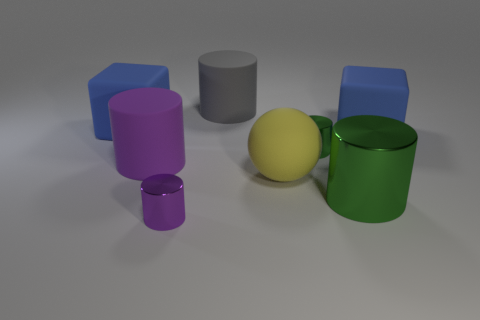Subtract all gray cylinders. How many cylinders are left? 4 Subtract all big gray matte cylinders. How many cylinders are left? 4 Subtract all brown cylinders. Subtract all blue balls. How many cylinders are left? 5 Add 1 big rubber things. How many objects exist? 9 Subtract all cubes. How many objects are left? 6 Add 1 large yellow objects. How many large yellow objects exist? 2 Subtract 1 yellow balls. How many objects are left? 7 Subtract all big gray cylinders. Subtract all yellow rubber things. How many objects are left? 6 Add 3 green cylinders. How many green cylinders are left? 5 